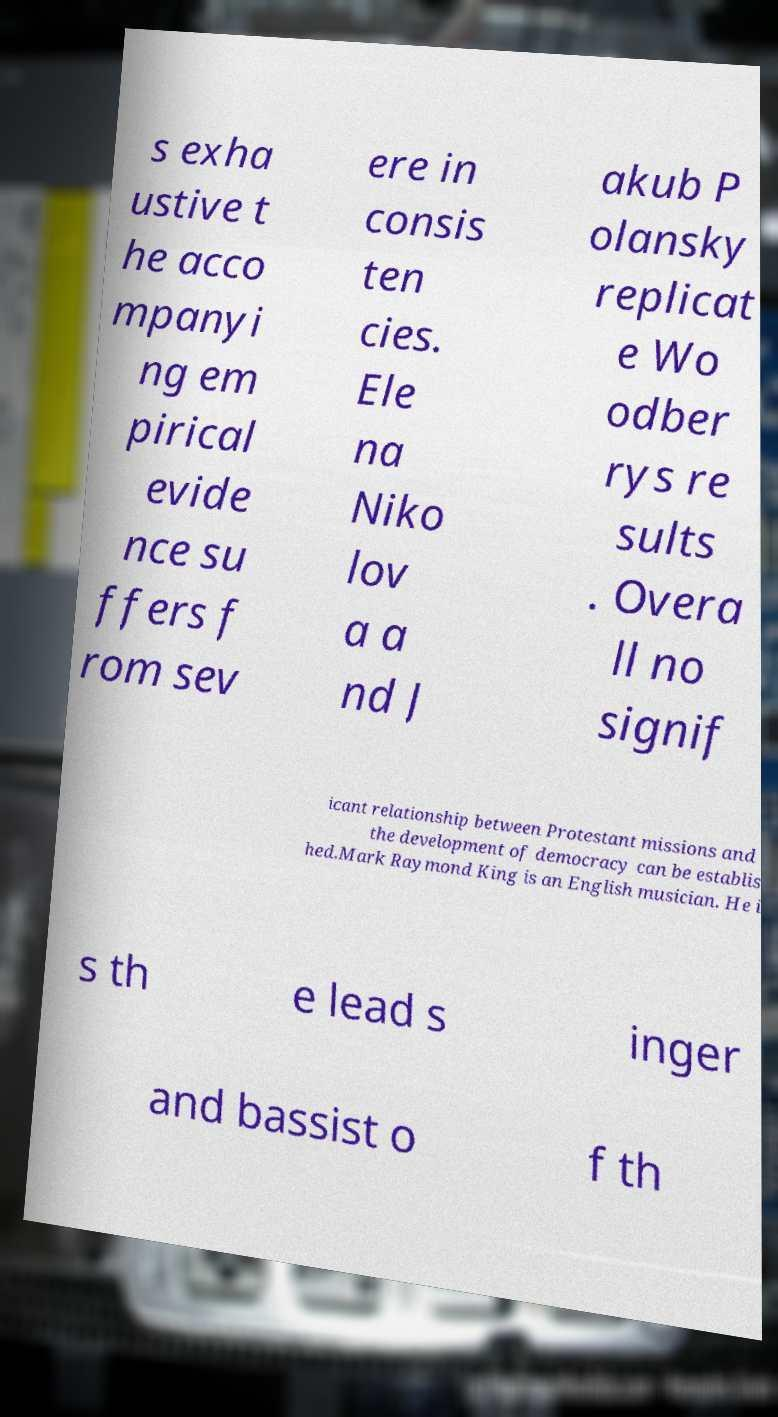For documentation purposes, I need the text within this image transcribed. Could you provide that? s exha ustive t he acco mpanyi ng em pirical evide nce su ffers f rom sev ere in consis ten cies. Ele na Niko lov a a nd J akub P olansky replicat e Wo odber rys re sults . Overa ll no signif icant relationship between Protestant missions and the development of democracy can be establis hed.Mark Raymond King is an English musician. He i s th e lead s inger and bassist o f th 